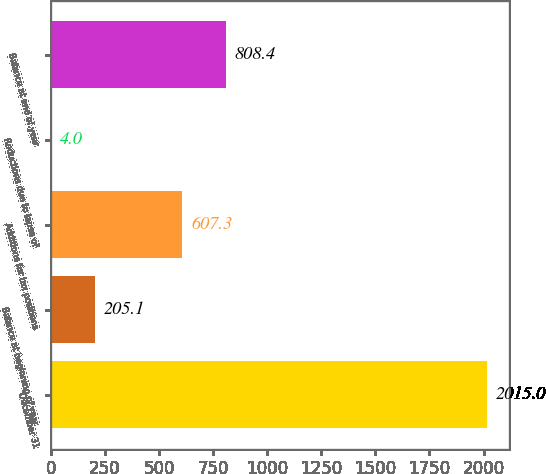<chart> <loc_0><loc_0><loc_500><loc_500><bar_chart><fcel>December 31<fcel>Balance at beginning of year<fcel>Additions for tax positions<fcel>Reductions due to lapse of<fcel>Balance at end of year<nl><fcel>2015<fcel>205.1<fcel>607.3<fcel>4<fcel>808.4<nl></chart> 